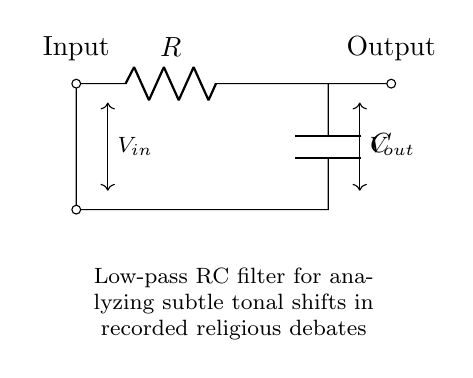What type of filter is represented in the circuit? The circuit is a low-pass filter, which allows signals with a frequency lower than a certain cutoff frequency to pass through while attenuating higher frequencies. This is identified by the arrangement of the resistor and capacitor in series, with the output taken across the capacitor.
Answer: low-pass filter What is the role of the resistor in this circuit? The resistor in this RC circuit regulates the charge and discharge rate of the capacitor. It influences the cutoff frequency of the low-pass filter by determining how quickly the capacitor can respond to changes in the input voltage. This is crucial for analyzing tonal shifts in debates.
Answer: regulates charge rate What is the component connected to the output? The output is connected to the capacitor, which is used to store charge and smooth out voltage fluctuations, allowing for more stable output measurement of the tonal shifts.
Answer: capacitor What type of analysis is this circuit used for? This low-pass RC filter is specifically used for analyzing subtle tonal shifts in recorded religious debates, as it isolates lower-frequency signals that can carry important nuances in speech.
Answer: tonal shifts What would happen if the resistance value is increased? Increasing the resistance would lower the cutoff frequency of the filter, allowing even slower signals to pass through while filtering out higher-frequency noise. This could make it more effective in isolating subtle tonal shifts.
Answer: lower cutoff frequency What is the relationship between the resistance, capacitance, and the cutoff frequency? The cutoff frequency is inversely related to both resistance and capacitance, defined by the formula 1/(2πRC). This means that an increase in either resistance or capacitance will decrease the cutoff frequency, impacting which signals pass through the filter.
Answer: inverse relationship How is the input voltage defined in this circuit? The input voltage is defined as the potential difference between the input terminal and ground, supplying the signal that is to be filtered by the RC circuit. This input is essential for observing how the circuit processes different tonal shifts.
Answer: potential difference 